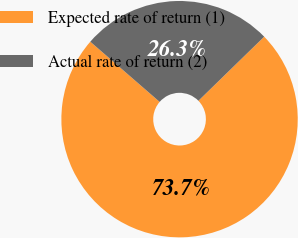<chart> <loc_0><loc_0><loc_500><loc_500><pie_chart><fcel>Expected rate of return (1)<fcel>Actual rate of return (2)<nl><fcel>73.67%<fcel>26.33%<nl></chart> 